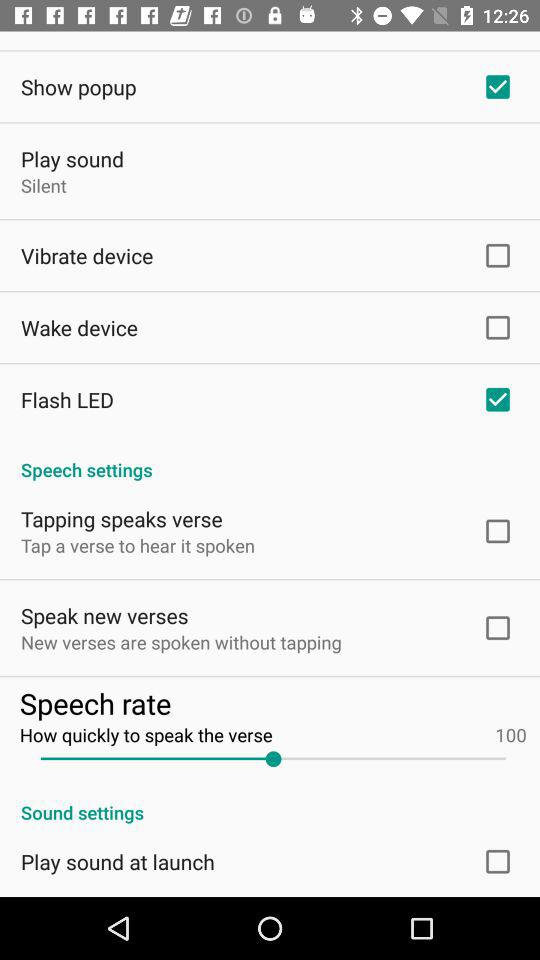What is the speech rate to speak the verse? The speech rate to speak the verse is 100. 